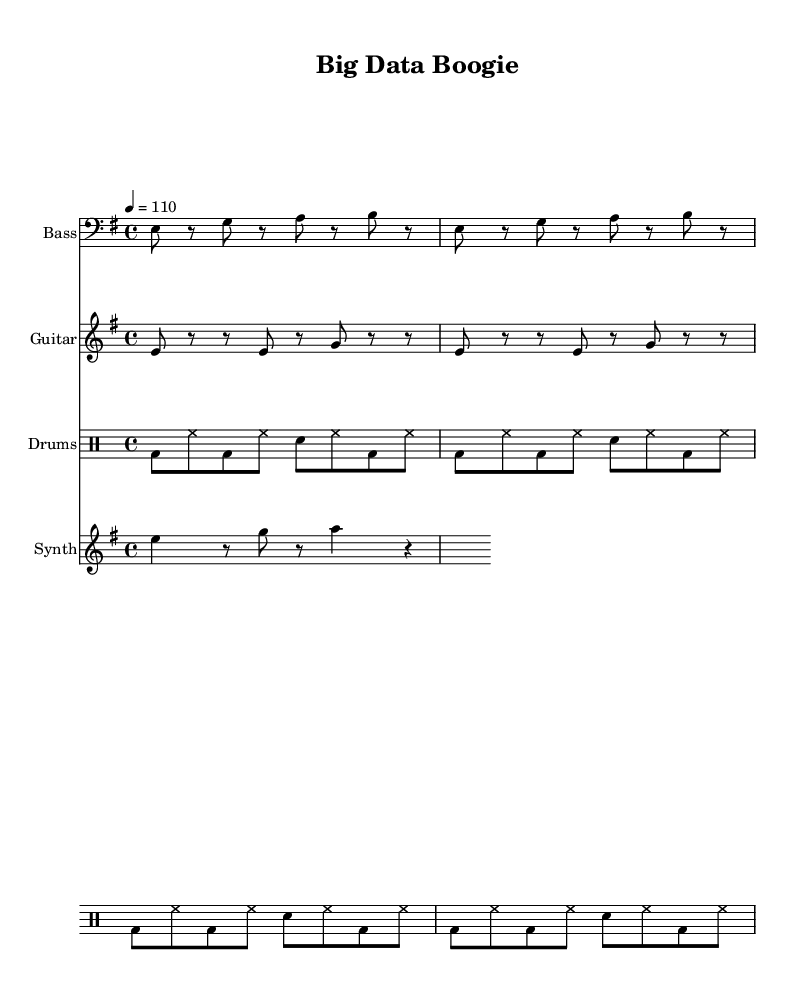What is the key signature of this music? The key signature is indicated at the beginning of the score with the "e" note, showing that there are one sharp (F#), placing the piece in E minor.
Answer: E minor What is the time signature of this music? The time signature is shown at the beginning of the score and is represented by "4/4," indicating there are four beats in each measure.
Answer: 4/4 What is the tempo marking for this piece? The tempo marking is indicated in the score with "4 = 110," specifying that there should be 110 beats per minute for the quarter note.
Answer: 110 How many measures are in the bass line? By counting the repetitions in the bass line, we see a total of 2 measures repeated twice, resulting in 4 measures overall.
Answer: 4 Which instrument has the melody line in the music? The instrument with the melody line is listed in the score under "Synth," which contains the main melody notes.
Answer: Synth What rhythmic pattern is used in the drum section? The drum section features a repeated pattern of bass drums (bd), hi-hats (hh), and snare (sn), tightly intertwining with the other instruments to create a cohesive groove common in funk.
Answer: BD - HH - SN How does the bass line contribute to the funk genre? The bass line is characterized by syncopation and rhythmic complexity, essential elements of funk, which create a "groovy" feel that encourages movement and dance.
Answer: Syncopation 